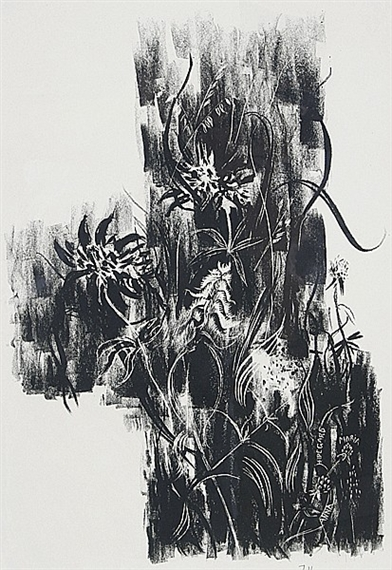Does this artwork remind you of any specific time or place? This artwork evokes a timeless, otherworldly quality, as if it belongs to a realm outside our conventional understanding of time and space. The abstract forms and fluid lines could represent a dreamscape or an alternate dimension, where the normal rules of reality do not apply. It could also recall the deep, untouched beauty of a primordial forest at twilight, where only the silhouettes of plant life are visible against the darkening sky. How would you feel if you could step into this artwork? Stepping into this artwork would feel like entering a world of constant motion and evolving shapes. It would be a disorienting yet exhilarating experience, like finding oneself in an ever-changing maze of light and shadow. The fluid lines would guide your path, but each step might reveal new patterns and textures. There would be a sense of wonder and discovery, tempered by the enigmatic and abstract nature of the surroundings. If you could give this artwork a title, what would it be? I would title this artwork 'Ethereal Dance,' capturing the sense of fluid, organic movement and the almost otherworldly quality of the lines and shapes. 